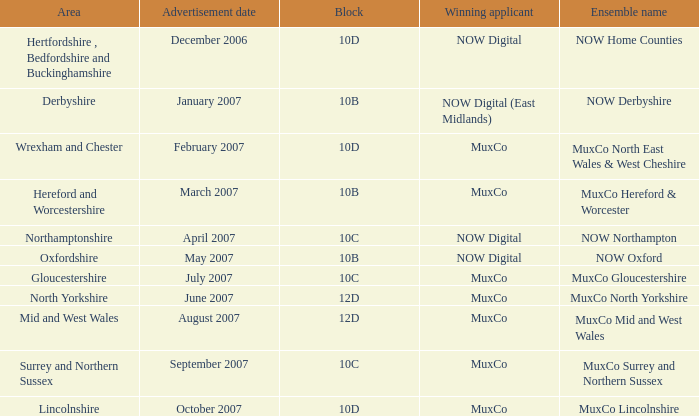What block is associated with the northamptonshire area? 10C. 